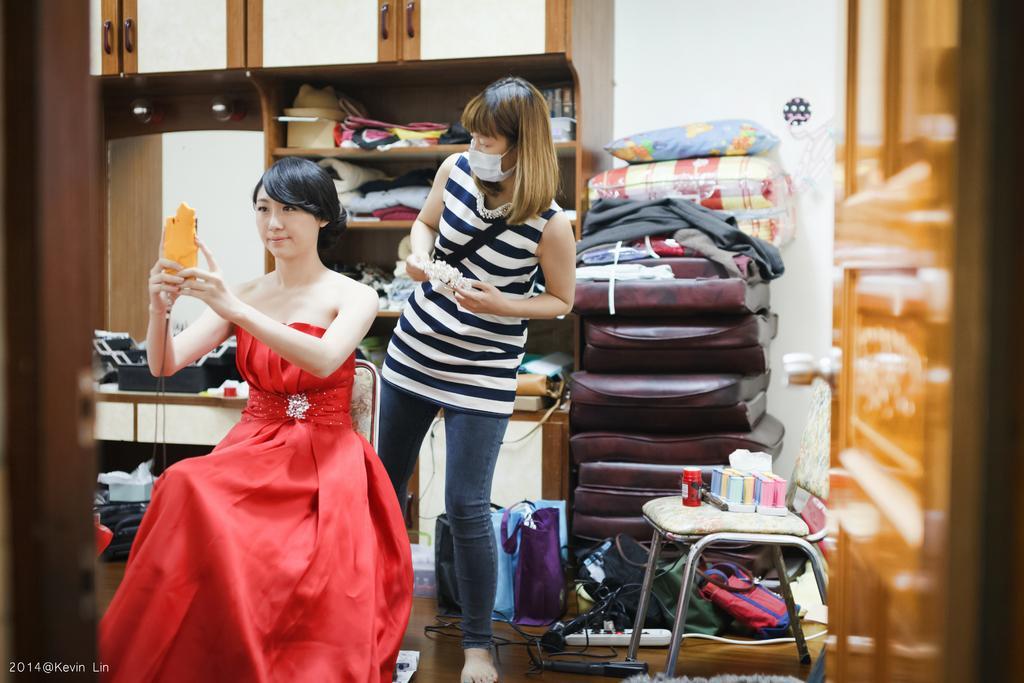Please provide a concise description of this image. This woman wore red dress and sitting on a chair. This woman wore t-shirt and mask. On this rock there are clothes and box. These are coats and pillows. On floor there are bags and cable. On this chair there are things. This woman is holding a mobile. This is cupboard. 